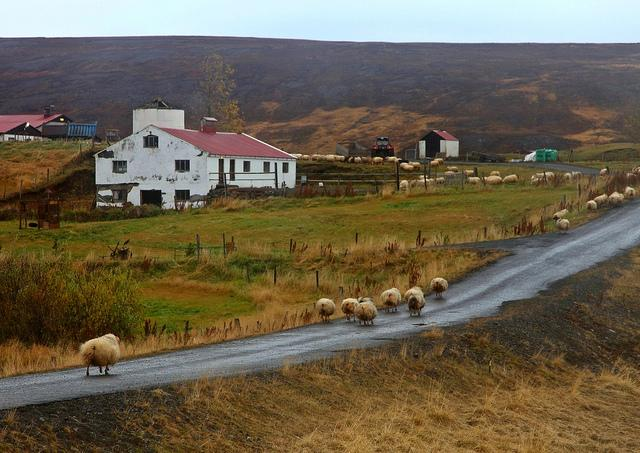What has caused the road to look slick? Please explain your reasoning. rain. The road looks like it is wet from the elements. 